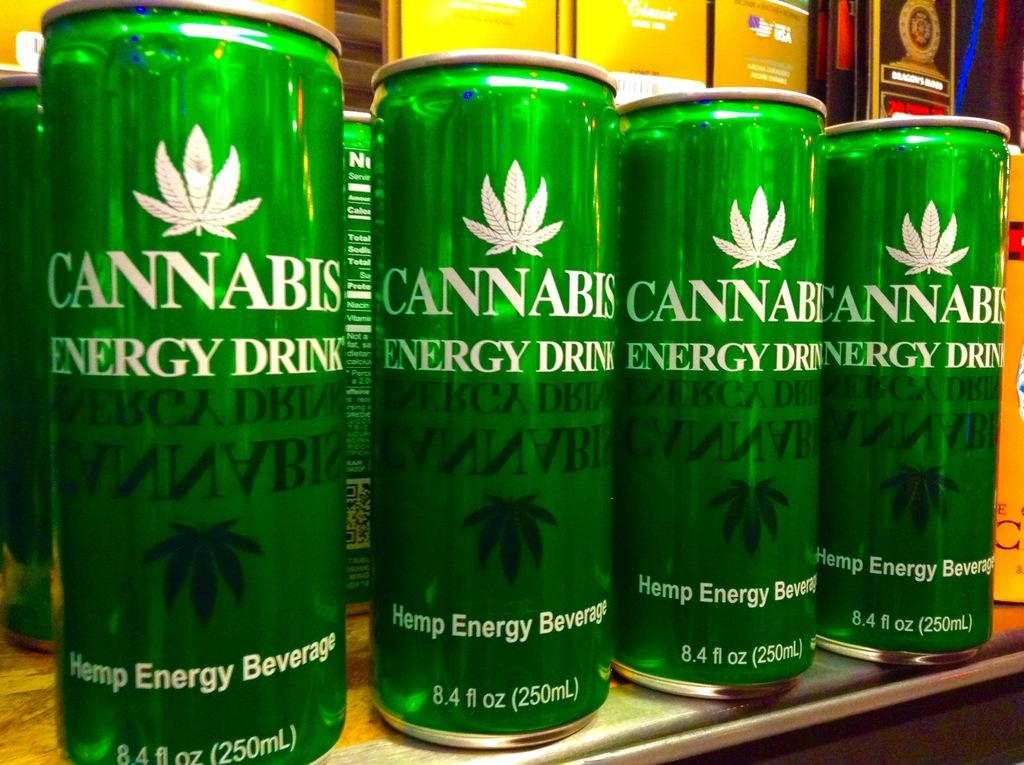<image>
Provide a brief description of the given image. Green Cannabis Energy drink cans aligned on the rack from Hamp Energy Beverage firf. 